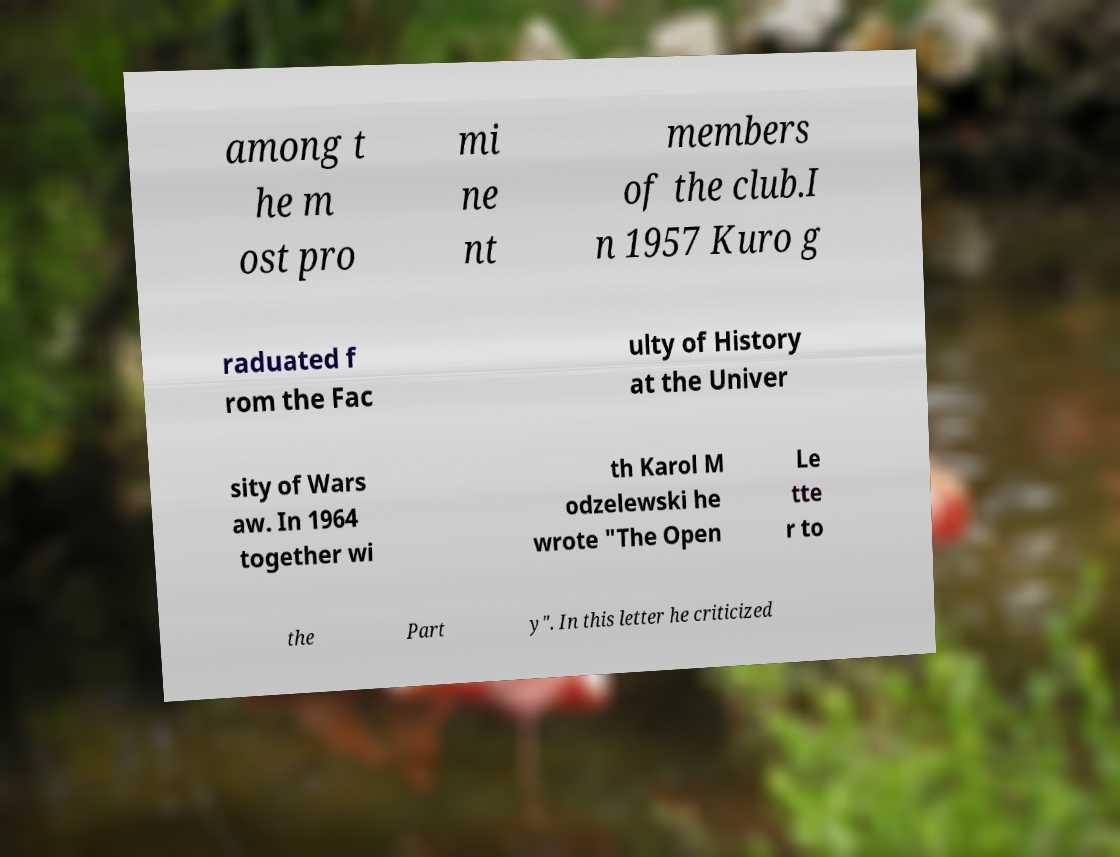Could you extract and type out the text from this image? among t he m ost pro mi ne nt members of the club.I n 1957 Kuro g raduated f rom the Fac ulty of History at the Univer sity of Wars aw. In 1964 together wi th Karol M odzelewski he wrote "The Open Le tte r to the Part y". In this letter he criticized 